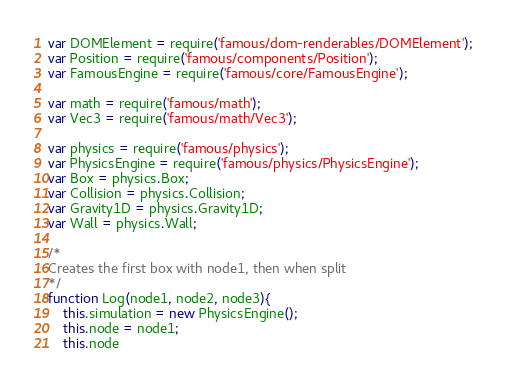<code> <loc_0><loc_0><loc_500><loc_500><_JavaScript_>var DOMElement = require('famous/dom-renderables/DOMElement');
var Position = require('famous/components/Position');
var FamousEngine = require('famous/core/FamousEngine');

var math = require('famous/math');
var Vec3 = require('famous/math/Vec3');

var physics = require('famous/physics');
var PhysicsEngine = require('famous/physics/PhysicsEngine');
var Box = physics.Box;
var Collision = physics.Collision;
var Gravity1D = physics.Gravity1D;
var Wall = physics.Wall;

/*
Creates the first box with node1, then when split
*/
function Log(node1, node2, node3){
	this.simulation = new PhysicsEngine();
	this.node = node1;
	this.node</code> 